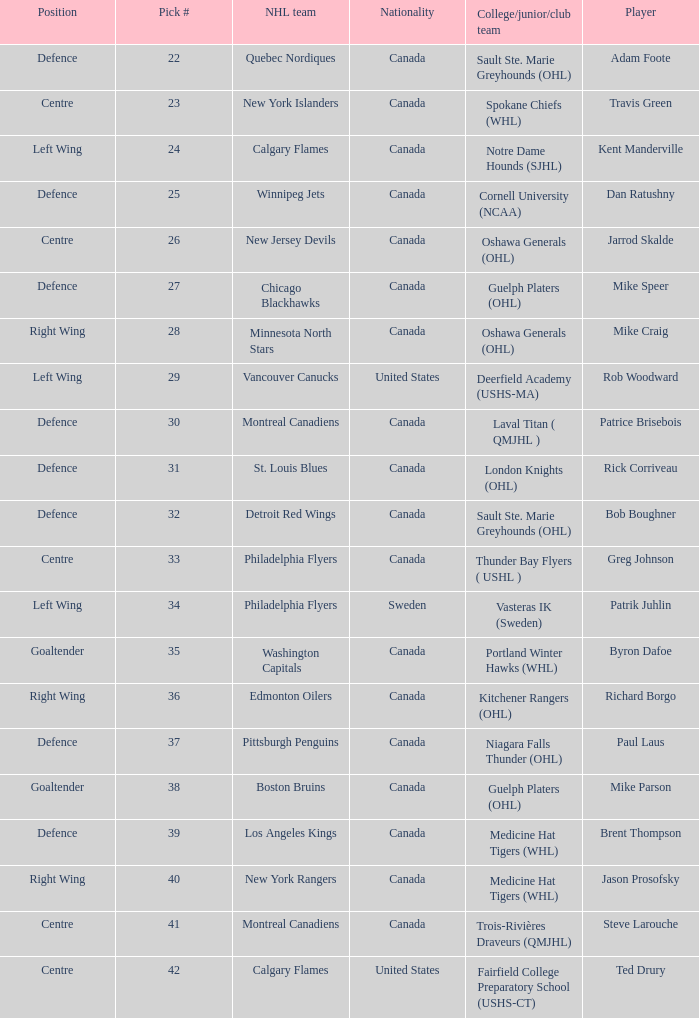What NHL team picked richard borgo? Edmonton Oilers. 